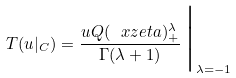<formula> <loc_0><loc_0><loc_500><loc_500>T ( u | _ { C } ) = \frac { u Q ( \ x z e t a ) _ { + } ^ { \lambda } } { \Gamma ( \lambda + 1 ) } \, \Big | _ { \lambda = - 1 }</formula> 